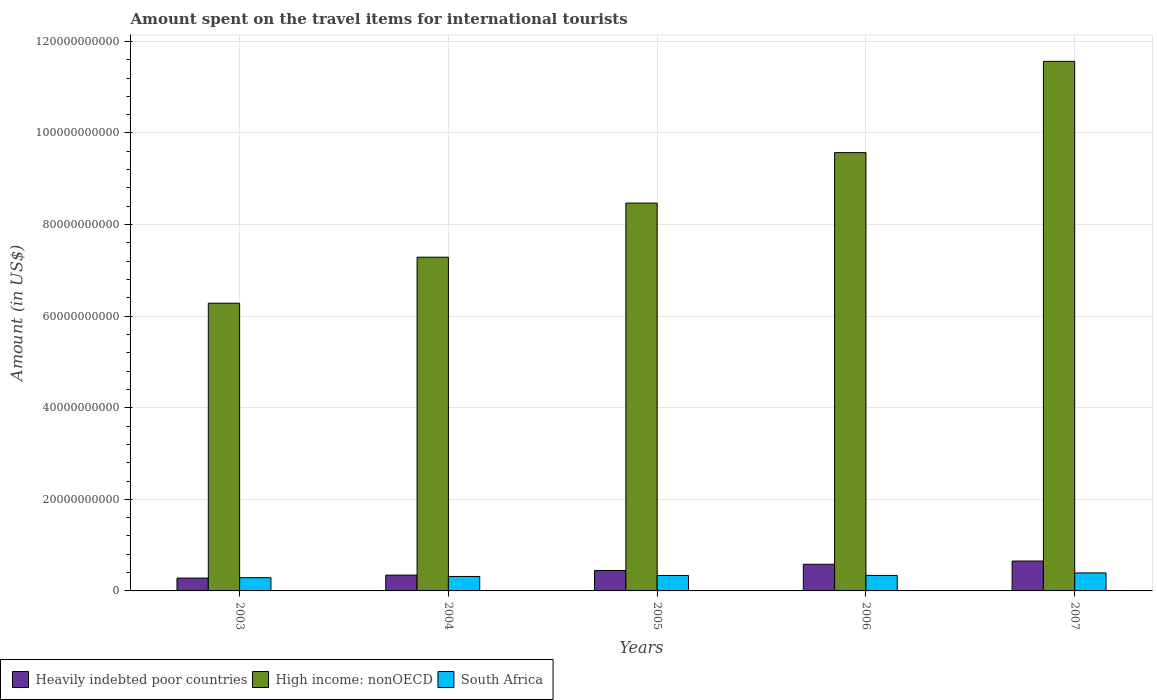How many groups of bars are there?
Your answer should be very brief. 5. Are the number of bars per tick equal to the number of legend labels?
Give a very brief answer. Yes. How many bars are there on the 4th tick from the left?
Offer a terse response. 3. What is the label of the 4th group of bars from the left?
Offer a very short reply. 2006. In how many cases, is the number of bars for a given year not equal to the number of legend labels?
Provide a short and direct response. 0. What is the amount spent on the travel items for international tourists in Heavily indebted poor countries in 2005?
Offer a terse response. 4.46e+09. Across all years, what is the maximum amount spent on the travel items for international tourists in South Africa?
Keep it short and to the point. 3.93e+09. Across all years, what is the minimum amount spent on the travel items for international tourists in High income: nonOECD?
Keep it short and to the point. 6.28e+1. What is the total amount spent on the travel items for international tourists in Heavily indebted poor countries in the graph?
Offer a very short reply. 2.31e+1. What is the difference between the amount spent on the travel items for international tourists in Heavily indebted poor countries in 2004 and that in 2007?
Provide a succinct answer. -3.08e+09. What is the difference between the amount spent on the travel items for international tourists in South Africa in 2003 and the amount spent on the travel items for international tourists in Heavily indebted poor countries in 2005?
Give a very brief answer. -1.57e+09. What is the average amount spent on the travel items for international tourists in South Africa per year?
Provide a succinct answer. 3.35e+09. In the year 2006, what is the difference between the amount spent on the travel items for international tourists in South Africa and amount spent on the travel items for international tourists in High income: nonOECD?
Your answer should be compact. -9.23e+1. What is the ratio of the amount spent on the travel items for international tourists in High income: nonOECD in 2003 to that in 2005?
Your answer should be compact. 0.74. Is the difference between the amount spent on the travel items for international tourists in South Africa in 2004 and 2007 greater than the difference between the amount spent on the travel items for international tourists in High income: nonOECD in 2004 and 2007?
Your answer should be compact. Yes. What is the difference between the highest and the second highest amount spent on the travel items for international tourists in High income: nonOECD?
Offer a terse response. 1.99e+1. What is the difference between the highest and the lowest amount spent on the travel items for international tourists in South Africa?
Provide a short and direct response. 1.04e+09. Is the sum of the amount spent on the travel items for international tourists in South Africa in 2003 and 2004 greater than the maximum amount spent on the travel items for international tourists in High income: nonOECD across all years?
Make the answer very short. No. What does the 3rd bar from the left in 2006 represents?
Give a very brief answer. South Africa. What does the 3rd bar from the right in 2006 represents?
Keep it short and to the point. Heavily indebted poor countries. Are all the bars in the graph horizontal?
Ensure brevity in your answer.  No. How many years are there in the graph?
Keep it short and to the point. 5. What is the difference between two consecutive major ticks on the Y-axis?
Provide a succinct answer. 2.00e+1. Does the graph contain grids?
Make the answer very short. Yes. How many legend labels are there?
Keep it short and to the point. 3. How are the legend labels stacked?
Provide a short and direct response. Horizontal. What is the title of the graph?
Offer a terse response. Amount spent on the travel items for international tourists. What is the label or title of the X-axis?
Your answer should be compact. Years. What is the Amount (in US$) of Heavily indebted poor countries in 2003?
Your answer should be compact. 2.81e+09. What is the Amount (in US$) in High income: nonOECD in 2003?
Give a very brief answer. 6.28e+1. What is the Amount (in US$) of South Africa in 2003?
Offer a very short reply. 2.89e+09. What is the Amount (in US$) of Heavily indebted poor countries in 2004?
Make the answer very short. 3.45e+09. What is the Amount (in US$) in High income: nonOECD in 2004?
Your answer should be very brief. 7.29e+1. What is the Amount (in US$) in South Africa in 2004?
Make the answer very short. 3.16e+09. What is the Amount (in US$) in Heavily indebted poor countries in 2005?
Keep it short and to the point. 4.46e+09. What is the Amount (in US$) in High income: nonOECD in 2005?
Ensure brevity in your answer.  8.47e+1. What is the Amount (in US$) of South Africa in 2005?
Provide a short and direct response. 3.37e+09. What is the Amount (in US$) in Heavily indebted poor countries in 2006?
Provide a short and direct response. 5.82e+09. What is the Amount (in US$) in High income: nonOECD in 2006?
Provide a succinct answer. 9.57e+1. What is the Amount (in US$) of South Africa in 2006?
Make the answer very short. 3.38e+09. What is the Amount (in US$) in Heavily indebted poor countries in 2007?
Ensure brevity in your answer.  6.53e+09. What is the Amount (in US$) of High income: nonOECD in 2007?
Provide a short and direct response. 1.16e+11. What is the Amount (in US$) in South Africa in 2007?
Provide a short and direct response. 3.93e+09. Across all years, what is the maximum Amount (in US$) of Heavily indebted poor countries?
Give a very brief answer. 6.53e+09. Across all years, what is the maximum Amount (in US$) of High income: nonOECD?
Provide a succinct answer. 1.16e+11. Across all years, what is the maximum Amount (in US$) in South Africa?
Your response must be concise. 3.93e+09. Across all years, what is the minimum Amount (in US$) of Heavily indebted poor countries?
Keep it short and to the point. 2.81e+09. Across all years, what is the minimum Amount (in US$) of High income: nonOECD?
Provide a succinct answer. 6.28e+1. Across all years, what is the minimum Amount (in US$) in South Africa?
Provide a succinct answer. 2.89e+09. What is the total Amount (in US$) in Heavily indebted poor countries in the graph?
Ensure brevity in your answer.  2.31e+1. What is the total Amount (in US$) in High income: nonOECD in the graph?
Make the answer very short. 4.32e+11. What is the total Amount (in US$) of South Africa in the graph?
Offer a terse response. 1.67e+1. What is the difference between the Amount (in US$) in Heavily indebted poor countries in 2003 and that in 2004?
Keep it short and to the point. -6.42e+08. What is the difference between the Amount (in US$) of High income: nonOECD in 2003 and that in 2004?
Provide a succinct answer. -1.00e+1. What is the difference between the Amount (in US$) in South Africa in 2003 and that in 2004?
Provide a succinct answer. -2.68e+08. What is the difference between the Amount (in US$) in Heavily indebted poor countries in 2003 and that in 2005?
Offer a terse response. -1.65e+09. What is the difference between the Amount (in US$) of High income: nonOECD in 2003 and that in 2005?
Give a very brief answer. -2.19e+1. What is the difference between the Amount (in US$) of South Africa in 2003 and that in 2005?
Your answer should be compact. -4.85e+08. What is the difference between the Amount (in US$) of Heavily indebted poor countries in 2003 and that in 2006?
Make the answer very short. -3.01e+09. What is the difference between the Amount (in US$) in High income: nonOECD in 2003 and that in 2006?
Your answer should be very brief. -3.29e+1. What is the difference between the Amount (in US$) in South Africa in 2003 and that in 2006?
Your answer should be very brief. -4.95e+08. What is the difference between the Amount (in US$) in Heavily indebted poor countries in 2003 and that in 2007?
Offer a terse response. -3.72e+09. What is the difference between the Amount (in US$) of High income: nonOECD in 2003 and that in 2007?
Offer a very short reply. -5.28e+1. What is the difference between the Amount (in US$) in South Africa in 2003 and that in 2007?
Provide a succinct answer. -1.04e+09. What is the difference between the Amount (in US$) of Heavily indebted poor countries in 2004 and that in 2005?
Keep it short and to the point. -1.01e+09. What is the difference between the Amount (in US$) of High income: nonOECD in 2004 and that in 2005?
Provide a succinct answer. -1.18e+1. What is the difference between the Amount (in US$) in South Africa in 2004 and that in 2005?
Your response must be concise. -2.17e+08. What is the difference between the Amount (in US$) of Heavily indebted poor countries in 2004 and that in 2006?
Provide a short and direct response. -2.37e+09. What is the difference between the Amount (in US$) of High income: nonOECD in 2004 and that in 2006?
Offer a very short reply. -2.28e+1. What is the difference between the Amount (in US$) in South Africa in 2004 and that in 2006?
Your response must be concise. -2.27e+08. What is the difference between the Amount (in US$) of Heavily indebted poor countries in 2004 and that in 2007?
Give a very brief answer. -3.08e+09. What is the difference between the Amount (in US$) in High income: nonOECD in 2004 and that in 2007?
Keep it short and to the point. -4.28e+1. What is the difference between the Amount (in US$) of South Africa in 2004 and that in 2007?
Your answer should be compact. -7.70e+08. What is the difference between the Amount (in US$) of Heavily indebted poor countries in 2005 and that in 2006?
Ensure brevity in your answer.  -1.36e+09. What is the difference between the Amount (in US$) in High income: nonOECD in 2005 and that in 2006?
Offer a terse response. -1.10e+1. What is the difference between the Amount (in US$) in South Africa in 2005 and that in 2006?
Ensure brevity in your answer.  -1.00e+07. What is the difference between the Amount (in US$) of Heavily indebted poor countries in 2005 and that in 2007?
Your response must be concise. -2.06e+09. What is the difference between the Amount (in US$) in High income: nonOECD in 2005 and that in 2007?
Ensure brevity in your answer.  -3.09e+1. What is the difference between the Amount (in US$) of South Africa in 2005 and that in 2007?
Give a very brief answer. -5.53e+08. What is the difference between the Amount (in US$) of Heavily indebted poor countries in 2006 and that in 2007?
Keep it short and to the point. -7.06e+08. What is the difference between the Amount (in US$) in High income: nonOECD in 2006 and that in 2007?
Make the answer very short. -1.99e+1. What is the difference between the Amount (in US$) of South Africa in 2006 and that in 2007?
Your answer should be very brief. -5.43e+08. What is the difference between the Amount (in US$) in Heavily indebted poor countries in 2003 and the Amount (in US$) in High income: nonOECD in 2004?
Ensure brevity in your answer.  -7.01e+1. What is the difference between the Amount (in US$) in Heavily indebted poor countries in 2003 and the Amount (in US$) in South Africa in 2004?
Your response must be concise. -3.50e+08. What is the difference between the Amount (in US$) in High income: nonOECD in 2003 and the Amount (in US$) in South Africa in 2004?
Keep it short and to the point. 5.97e+1. What is the difference between the Amount (in US$) in Heavily indebted poor countries in 2003 and the Amount (in US$) in High income: nonOECD in 2005?
Your answer should be very brief. -8.19e+1. What is the difference between the Amount (in US$) of Heavily indebted poor countries in 2003 and the Amount (in US$) of South Africa in 2005?
Ensure brevity in your answer.  -5.67e+08. What is the difference between the Amount (in US$) of High income: nonOECD in 2003 and the Amount (in US$) of South Africa in 2005?
Keep it short and to the point. 5.95e+1. What is the difference between the Amount (in US$) in Heavily indebted poor countries in 2003 and the Amount (in US$) in High income: nonOECD in 2006?
Your answer should be very brief. -9.29e+1. What is the difference between the Amount (in US$) of Heavily indebted poor countries in 2003 and the Amount (in US$) of South Africa in 2006?
Ensure brevity in your answer.  -5.77e+08. What is the difference between the Amount (in US$) in High income: nonOECD in 2003 and the Amount (in US$) in South Africa in 2006?
Your answer should be compact. 5.94e+1. What is the difference between the Amount (in US$) in Heavily indebted poor countries in 2003 and the Amount (in US$) in High income: nonOECD in 2007?
Offer a very short reply. -1.13e+11. What is the difference between the Amount (in US$) of Heavily indebted poor countries in 2003 and the Amount (in US$) of South Africa in 2007?
Offer a very short reply. -1.12e+09. What is the difference between the Amount (in US$) in High income: nonOECD in 2003 and the Amount (in US$) in South Africa in 2007?
Provide a short and direct response. 5.89e+1. What is the difference between the Amount (in US$) in Heavily indebted poor countries in 2004 and the Amount (in US$) in High income: nonOECD in 2005?
Your answer should be very brief. -8.12e+1. What is the difference between the Amount (in US$) in Heavily indebted poor countries in 2004 and the Amount (in US$) in South Africa in 2005?
Your answer should be very brief. 7.50e+07. What is the difference between the Amount (in US$) of High income: nonOECD in 2004 and the Amount (in US$) of South Africa in 2005?
Give a very brief answer. 6.95e+1. What is the difference between the Amount (in US$) in Heavily indebted poor countries in 2004 and the Amount (in US$) in High income: nonOECD in 2006?
Your answer should be very brief. -9.23e+1. What is the difference between the Amount (in US$) of Heavily indebted poor countries in 2004 and the Amount (in US$) of South Africa in 2006?
Offer a very short reply. 6.50e+07. What is the difference between the Amount (in US$) of High income: nonOECD in 2004 and the Amount (in US$) of South Africa in 2006?
Ensure brevity in your answer.  6.95e+1. What is the difference between the Amount (in US$) of Heavily indebted poor countries in 2004 and the Amount (in US$) of High income: nonOECD in 2007?
Offer a very short reply. -1.12e+11. What is the difference between the Amount (in US$) of Heavily indebted poor countries in 2004 and the Amount (in US$) of South Africa in 2007?
Provide a short and direct response. -4.78e+08. What is the difference between the Amount (in US$) of High income: nonOECD in 2004 and the Amount (in US$) of South Africa in 2007?
Keep it short and to the point. 6.89e+1. What is the difference between the Amount (in US$) in Heavily indebted poor countries in 2005 and the Amount (in US$) in High income: nonOECD in 2006?
Give a very brief answer. -9.12e+1. What is the difference between the Amount (in US$) in Heavily indebted poor countries in 2005 and the Amount (in US$) in South Africa in 2006?
Provide a succinct answer. 1.08e+09. What is the difference between the Amount (in US$) in High income: nonOECD in 2005 and the Amount (in US$) in South Africa in 2006?
Ensure brevity in your answer.  8.13e+1. What is the difference between the Amount (in US$) in Heavily indebted poor countries in 2005 and the Amount (in US$) in High income: nonOECD in 2007?
Keep it short and to the point. -1.11e+11. What is the difference between the Amount (in US$) in Heavily indebted poor countries in 2005 and the Amount (in US$) in South Africa in 2007?
Make the answer very short. 5.35e+08. What is the difference between the Amount (in US$) in High income: nonOECD in 2005 and the Amount (in US$) in South Africa in 2007?
Provide a short and direct response. 8.08e+1. What is the difference between the Amount (in US$) in Heavily indebted poor countries in 2006 and the Amount (in US$) in High income: nonOECD in 2007?
Give a very brief answer. -1.10e+11. What is the difference between the Amount (in US$) of Heavily indebted poor countries in 2006 and the Amount (in US$) of South Africa in 2007?
Keep it short and to the point. 1.89e+09. What is the difference between the Amount (in US$) of High income: nonOECD in 2006 and the Amount (in US$) of South Africa in 2007?
Offer a very short reply. 9.18e+1. What is the average Amount (in US$) in Heavily indebted poor countries per year?
Offer a terse response. 4.61e+09. What is the average Amount (in US$) of High income: nonOECD per year?
Ensure brevity in your answer.  8.63e+1. What is the average Amount (in US$) of South Africa per year?
Your response must be concise. 3.35e+09. In the year 2003, what is the difference between the Amount (in US$) in Heavily indebted poor countries and Amount (in US$) in High income: nonOECD?
Provide a short and direct response. -6.00e+1. In the year 2003, what is the difference between the Amount (in US$) in Heavily indebted poor countries and Amount (in US$) in South Africa?
Your answer should be very brief. -8.17e+07. In the year 2003, what is the difference between the Amount (in US$) of High income: nonOECD and Amount (in US$) of South Africa?
Ensure brevity in your answer.  5.99e+1. In the year 2004, what is the difference between the Amount (in US$) in Heavily indebted poor countries and Amount (in US$) in High income: nonOECD?
Keep it short and to the point. -6.94e+1. In the year 2004, what is the difference between the Amount (in US$) of Heavily indebted poor countries and Amount (in US$) of South Africa?
Ensure brevity in your answer.  2.92e+08. In the year 2004, what is the difference between the Amount (in US$) in High income: nonOECD and Amount (in US$) in South Africa?
Give a very brief answer. 6.97e+1. In the year 2005, what is the difference between the Amount (in US$) of Heavily indebted poor countries and Amount (in US$) of High income: nonOECD?
Offer a terse response. -8.02e+1. In the year 2005, what is the difference between the Amount (in US$) in Heavily indebted poor countries and Amount (in US$) in South Africa?
Your answer should be compact. 1.09e+09. In the year 2005, what is the difference between the Amount (in US$) in High income: nonOECD and Amount (in US$) in South Africa?
Your answer should be compact. 8.13e+1. In the year 2006, what is the difference between the Amount (in US$) in Heavily indebted poor countries and Amount (in US$) in High income: nonOECD?
Offer a terse response. -8.99e+1. In the year 2006, what is the difference between the Amount (in US$) in Heavily indebted poor countries and Amount (in US$) in South Africa?
Your response must be concise. 2.43e+09. In the year 2006, what is the difference between the Amount (in US$) of High income: nonOECD and Amount (in US$) of South Africa?
Ensure brevity in your answer.  9.23e+1. In the year 2007, what is the difference between the Amount (in US$) of Heavily indebted poor countries and Amount (in US$) of High income: nonOECD?
Ensure brevity in your answer.  -1.09e+11. In the year 2007, what is the difference between the Amount (in US$) of Heavily indebted poor countries and Amount (in US$) of South Africa?
Your response must be concise. 2.60e+09. In the year 2007, what is the difference between the Amount (in US$) of High income: nonOECD and Amount (in US$) of South Africa?
Offer a very short reply. 1.12e+11. What is the ratio of the Amount (in US$) in Heavily indebted poor countries in 2003 to that in 2004?
Offer a very short reply. 0.81. What is the ratio of the Amount (in US$) in High income: nonOECD in 2003 to that in 2004?
Provide a short and direct response. 0.86. What is the ratio of the Amount (in US$) in South Africa in 2003 to that in 2004?
Your answer should be compact. 0.92. What is the ratio of the Amount (in US$) in Heavily indebted poor countries in 2003 to that in 2005?
Your answer should be compact. 0.63. What is the ratio of the Amount (in US$) in High income: nonOECD in 2003 to that in 2005?
Your answer should be very brief. 0.74. What is the ratio of the Amount (in US$) of South Africa in 2003 to that in 2005?
Provide a succinct answer. 0.86. What is the ratio of the Amount (in US$) of Heavily indebted poor countries in 2003 to that in 2006?
Your answer should be compact. 0.48. What is the ratio of the Amount (in US$) of High income: nonOECD in 2003 to that in 2006?
Offer a terse response. 0.66. What is the ratio of the Amount (in US$) of South Africa in 2003 to that in 2006?
Keep it short and to the point. 0.85. What is the ratio of the Amount (in US$) of Heavily indebted poor countries in 2003 to that in 2007?
Provide a short and direct response. 0.43. What is the ratio of the Amount (in US$) in High income: nonOECD in 2003 to that in 2007?
Offer a very short reply. 0.54. What is the ratio of the Amount (in US$) in South Africa in 2003 to that in 2007?
Keep it short and to the point. 0.74. What is the ratio of the Amount (in US$) of Heavily indebted poor countries in 2004 to that in 2005?
Provide a succinct answer. 0.77. What is the ratio of the Amount (in US$) in High income: nonOECD in 2004 to that in 2005?
Offer a terse response. 0.86. What is the ratio of the Amount (in US$) of South Africa in 2004 to that in 2005?
Ensure brevity in your answer.  0.94. What is the ratio of the Amount (in US$) in Heavily indebted poor countries in 2004 to that in 2006?
Ensure brevity in your answer.  0.59. What is the ratio of the Amount (in US$) of High income: nonOECD in 2004 to that in 2006?
Give a very brief answer. 0.76. What is the ratio of the Amount (in US$) in South Africa in 2004 to that in 2006?
Provide a short and direct response. 0.93. What is the ratio of the Amount (in US$) in Heavily indebted poor countries in 2004 to that in 2007?
Your answer should be very brief. 0.53. What is the ratio of the Amount (in US$) of High income: nonOECD in 2004 to that in 2007?
Make the answer very short. 0.63. What is the ratio of the Amount (in US$) of South Africa in 2004 to that in 2007?
Give a very brief answer. 0.8. What is the ratio of the Amount (in US$) in Heavily indebted poor countries in 2005 to that in 2006?
Make the answer very short. 0.77. What is the ratio of the Amount (in US$) of High income: nonOECD in 2005 to that in 2006?
Provide a short and direct response. 0.88. What is the ratio of the Amount (in US$) in South Africa in 2005 to that in 2006?
Your answer should be very brief. 1. What is the ratio of the Amount (in US$) of Heavily indebted poor countries in 2005 to that in 2007?
Provide a succinct answer. 0.68. What is the ratio of the Amount (in US$) in High income: nonOECD in 2005 to that in 2007?
Keep it short and to the point. 0.73. What is the ratio of the Amount (in US$) in South Africa in 2005 to that in 2007?
Offer a terse response. 0.86. What is the ratio of the Amount (in US$) of Heavily indebted poor countries in 2006 to that in 2007?
Provide a short and direct response. 0.89. What is the ratio of the Amount (in US$) in High income: nonOECD in 2006 to that in 2007?
Offer a terse response. 0.83. What is the ratio of the Amount (in US$) of South Africa in 2006 to that in 2007?
Your response must be concise. 0.86. What is the difference between the highest and the second highest Amount (in US$) of Heavily indebted poor countries?
Your answer should be very brief. 7.06e+08. What is the difference between the highest and the second highest Amount (in US$) in High income: nonOECD?
Provide a short and direct response. 1.99e+1. What is the difference between the highest and the second highest Amount (in US$) of South Africa?
Offer a terse response. 5.43e+08. What is the difference between the highest and the lowest Amount (in US$) in Heavily indebted poor countries?
Your response must be concise. 3.72e+09. What is the difference between the highest and the lowest Amount (in US$) of High income: nonOECD?
Ensure brevity in your answer.  5.28e+1. What is the difference between the highest and the lowest Amount (in US$) of South Africa?
Provide a short and direct response. 1.04e+09. 